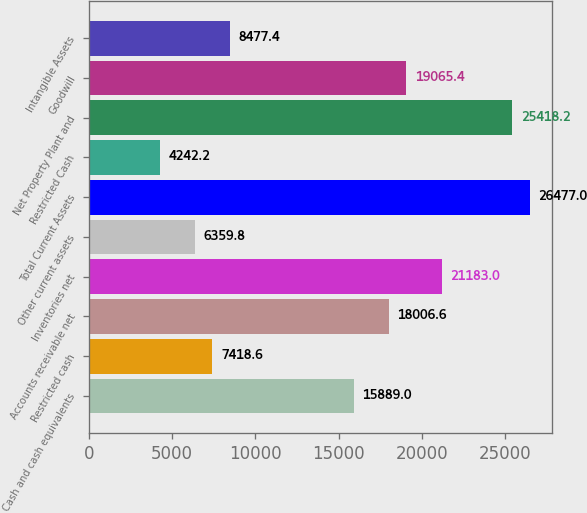Convert chart to OTSL. <chart><loc_0><loc_0><loc_500><loc_500><bar_chart><fcel>Cash and cash equivalents<fcel>Restricted cash<fcel>Accounts receivable net<fcel>Inventories net<fcel>Other current assets<fcel>Total Current Assets<fcel>Restricted Cash<fcel>Net Property Plant and<fcel>Goodwill<fcel>Intangible Assets<nl><fcel>15889<fcel>7418.6<fcel>18006.6<fcel>21183<fcel>6359.8<fcel>26477<fcel>4242.2<fcel>25418.2<fcel>19065.4<fcel>8477.4<nl></chart> 